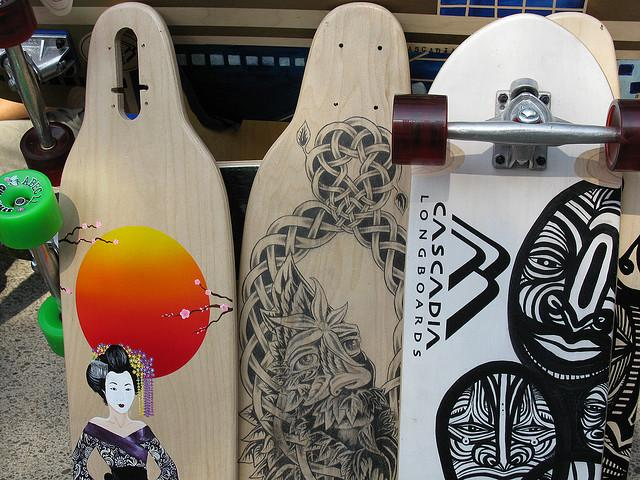This board is used for what sport?

Choices:
A) skating
B) skateboarding
C) surfing
D) skiing skateboarding 